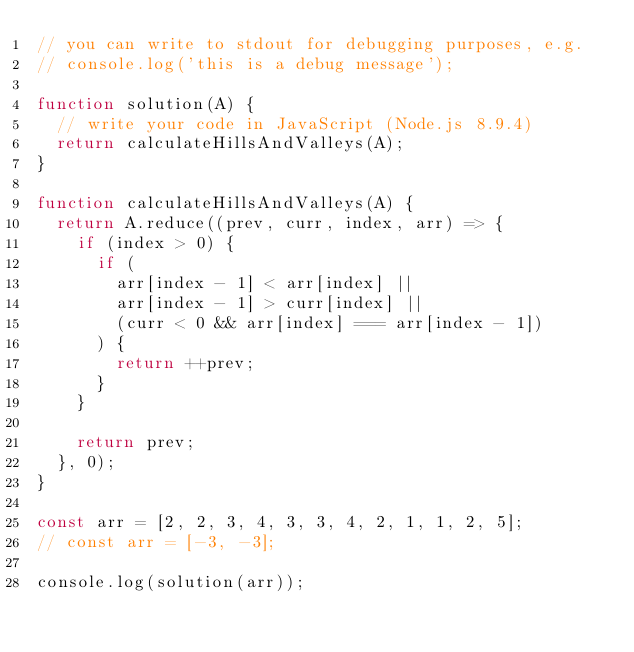Convert code to text. <code><loc_0><loc_0><loc_500><loc_500><_JavaScript_>// you can write to stdout for debugging purposes, e.g.
// console.log('this is a debug message');

function solution(A) {
  // write your code in JavaScript (Node.js 8.9.4)
  return calculateHillsAndValleys(A);
}

function calculateHillsAndValleys(A) {
  return A.reduce((prev, curr, index, arr) => {
    if (index > 0) {
      if (
        arr[index - 1] < arr[index] ||
        arr[index - 1] > curr[index] ||
        (curr < 0 && arr[index] === arr[index - 1])
      ) {
        return ++prev;
      }
    }

    return prev;
  }, 0);
}

const arr = [2, 2, 3, 4, 3, 3, 4, 2, 1, 1, 2, 5];
// const arr = [-3, -3];

console.log(solution(arr));
</code> 